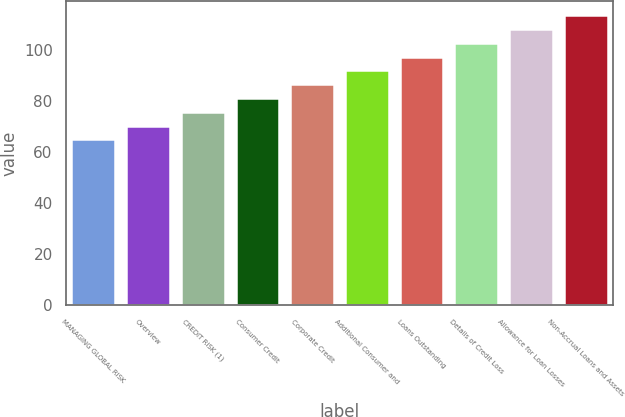Convert chart. <chart><loc_0><loc_0><loc_500><loc_500><bar_chart><fcel>MANAGING GLOBAL RISK<fcel>Overview<fcel>CREDIT RISK (1)<fcel>Consumer Credit<fcel>Corporate Credit<fcel>Additional Consumer and<fcel>Loans Outstanding<fcel>Details of Credit Loss<fcel>Allowance for Loan Losses<fcel>Non-Accrual Loans and Assets<nl><fcel>65<fcel>70.4<fcel>75.8<fcel>81.2<fcel>86.6<fcel>92<fcel>97.4<fcel>102.8<fcel>108.2<fcel>113.6<nl></chart> 